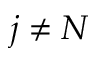Convert formula to latex. <formula><loc_0><loc_0><loc_500><loc_500>j \neq N</formula> 